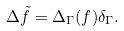Convert formula to latex. <formula><loc_0><loc_0><loc_500><loc_500>\Delta \tilde { f } = \Delta _ { \Gamma } ( f ) \delta _ { \Gamma } .</formula> 